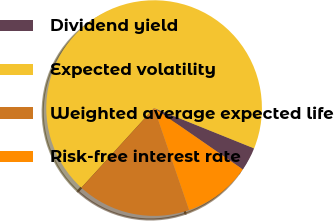<chart> <loc_0><loc_0><loc_500><loc_500><pie_chart><fcel>Dividend yield<fcel>Expected volatility<fcel>Weighted average expected life<fcel>Risk-free interest rate<nl><fcel>3.53%<fcel>69.33%<fcel>17.04%<fcel>10.11%<nl></chart> 